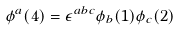<formula> <loc_0><loc_0><loc_500><loc_500>\phi ^ { a } ( 4 ) = \epsilon ^ { a b c } \phi _ { b } ( 1 ) \phi _ { c } ( 2 )</formula> 